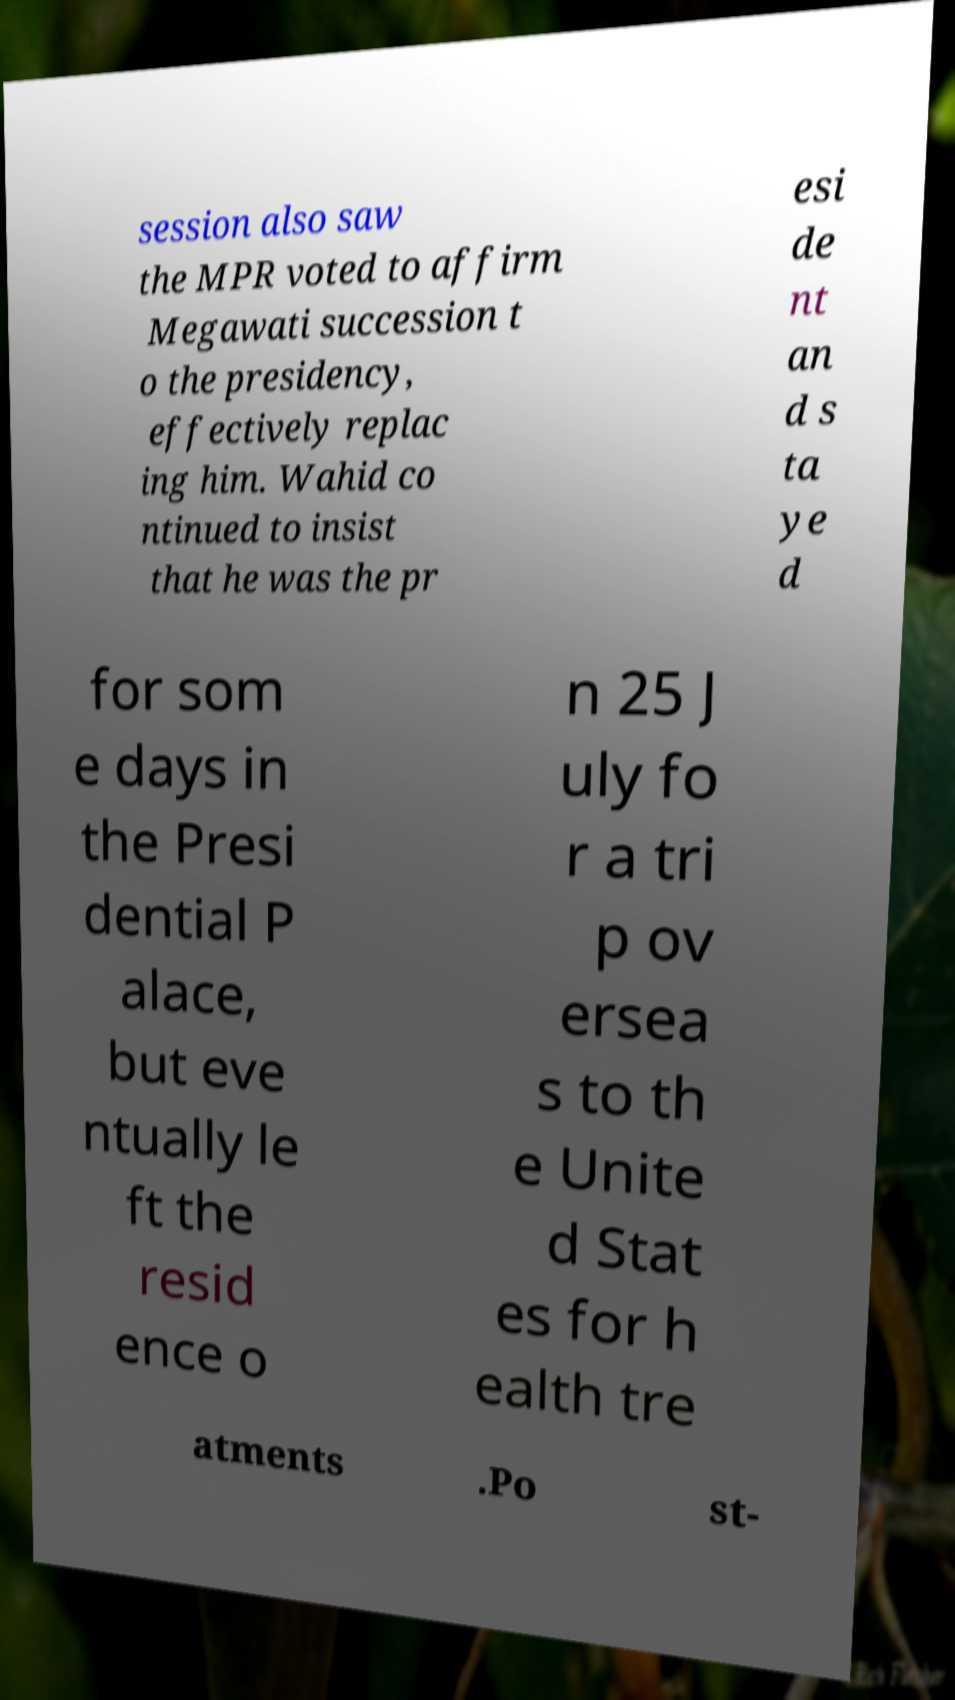Can you accurately transcribe the text from the provided image for me? session also saw the MPR voted to affirm Megawati succession t o the presidency, effectively replac ing him. Wahid co ntinued to insist that he was the pr esi de nt an d s ta ye d for som e days in the Presi dential P alace, but eve ntually le ft the resid ence o n 25 J uly fo r a tri p ov ersea s to th e Unite d Stat es for h ealth tre atments .Po st- 